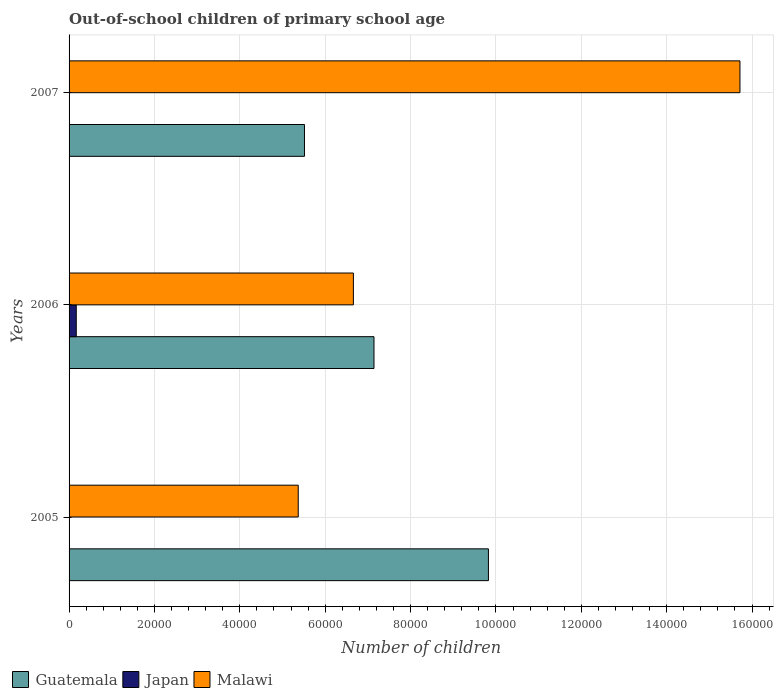How many different coloured bars are there?
Ensure brevity in your answer.  3. Are the number of bars on each tick of the Y-axis equal?
Your response must be concise. Yes. How many bars are there on the 2nd tick from the bottom?
Make the answer very short. 3. What is the label of the 2nd group of bars from the top?
Provide a short and direct response. 2006. What is the number of out-of-school children in Malawi in 2007?
Ensure brevity in your answer.  1.57e+05. Across all years, what is the maximum number of out-of-school children in Malawi?
Give a very brief answer. 1.57e+05. Across all years, what is the minimum number of out-of-school children in Japan?
Your response must be concise. 58. In which year was the number of out-of-school children in Guatemala maximum?
Keep it short and to the point. 2005. In which year was the number of out-of-school children in Japan minimum?
Provide a short and direct response. 2007. What is the total number of out-of-school children in Japan in the graph?
Your answer should be compact. 1843. What is the difference between the number of out-of-school children in Malawi in 2005 and that in 2006?
Give a very brief answer. -1.29e+04. What is the difference between the number of out-of-school children in Malawi in 2006 and the number of out-of-school children in Guatemala in 2007?
Offer a very short reply. 1.15e+04. What is the average number of out-of-school children in Malawi per year?
Make the answer very short. 9.25e+04. In the year 2007, what is the difference between the number of out-of-school children in Guatemala and number of out-of-school children in Malawi?
Give a very brief answer. -1.02e+05. In how many years, is the number of out-of-school children in Malawi greater than 144000 ?
Give a very brief answer. 1. What is the ratio of the number of out-of-school children in Malawi in 2006 to that in 2007?
Keep it short and to the point. 0.42. What is the difference between the highest and the second highest number of out-of-school children in Guatemala?
Keep it short and to the point. 2.68e+04. What is the difference between the highest and the lowest number of out-of-school children in Guatemala?
Ensure brevity in your answer.  4.31e+04. In how many years, is the number of out-of-school children in Guatemala greater than the average number of out-of-school children in Guatemala taken over all years?
Make the answer very short. 1. Is the sum of the number of out-of-school children in Japan in 2005 and 2007 greater than the maximum number of out-of-school children in Malawi across all years?
Provide a succinct answer. No. What does the 1st bar from the top in 2005 represents?
Keep it short and to the point. Malawi. What does the 2nd bar from the bottom in 2005 represents?
Offer a terse response. Japan. How many bars are there?
Provide a succinct answer. 9. Are all the bars in the graph horizontal?
Your response must be concise. Yes. How many years are there in the graph?
Give a very brief answer. 3. What is the difference between two consecutive major ticks on the X-axis?
Offer a terse response. 2.00e+04. Does the graph contain any zero values?
Your response must be concise. No. Does the graph contain grids?
Ensure brevity in your answer.  Yes. How are the legend labels stacked?
Provide a succinct answer. Horizontal. What is the title of the graph?
Your answer should be very brief. Out-of-school children of primary school age. What is the label or title of the X-axis?
Keep it short and to the point. Number of children. What is the label or title of the Y-axis?
Offer a terse response. Years. What is the Number of children in Guatemala in 2005?
Provide a succinct answer. 9.82e+04. What is the Number of children in Malawi in 2005?
Make the answer very short. 5.37e+04. What is the Number of children in Guatemala in 2006?
Offer a terse response. 7.14e+04. What is the Number of children of Japan in 2006?
Your response must be concise. 1685. What is the Number of children in Malawi in 2006?
Your response must be concise. 6.66e+04. What is the Number of children in Guatemala in 2007?
Provide a succinct answer. 5.51e+04. What is the Number of children in Malawi in 2007?
Your answer should be very brief. 1.57e+05. Across all years, what is the maximum Number of children in Guatemala?
Make the answer very short. 9.82e+04. Across all years, what is the maximum Number of children in Japan?
Provide a short and direct response. 1685. Across all years, what is the maximum Number of children in Malawi?
Offer a terse response. 1.57e+05. Across all years, what is the minimum Number of children in Guatemala?
Provide a short and direct response. 5.51e+04. Across all years, what is the minimum Number of children of Malawi?
Offer a terse response. 5.37e+04. What is the total Number of children in Guatemala in the graph?
Offer a very short reply. 2.25e+05. What is the total Number of children in Japan in the graph?
Provide a succinct answer. 1843. What is the total Number of children of Malawi in the graph?
Provide a succinct answer. 2.77e+05. What is the difference between the Number of children of Guatemala in 2005 and that in 2006?
Your answer should be very brief. 2.68e+04. What is the difference between the Number of children of Japan in 2005 and that in 2006?
Your answer should be very brief. -1585. What is the difference between the Number of children in Malawi in 2005 and that in 2006?
Keep it short and to the point. -1.29e+04. What is the difference between the Number of children in Guatemala in 2005 and that in 2007?
Offer a very short reply. 4.31e+04. What is the difference between the Number of children in Japan in 2005 and that in 2007?
Keep it short and to the point. 42. What is the difference between the Number of children of Malawi in 2005 and that in 2007?
Give a very brief answer. -1.03e+05. What is the difference between the Number of children in Guatemala in 2006 and that in 2007?
Give a very brief answer. 1.63e+04. What is the difference between the Number of children of Japan in 2006 and that in 2007?
Your response must be concise. 1627. What is the difference between the Number of children in Malawi in 2006 and that in 2007?
Make the answer very short. -9.06e+04. What is the difference between the Number of children in Guatemala in 2005 and the Number of children in Japan in 2006?
Ensure brevity in your answer.  9.66e+04. What is the difference between the Number of children in Guatemala in 2005 and the Number of children in Malawi in 2006?
Provide a succinct answer. 3.16e+04. What is the difference between the Number of children in Japan in 2005 and the Number of children in Malawi in 2006?
Give a very brief answer. -6.65e+04. What is the difference between the Number of children in Guatemala in 2005 and the Number of children in Japan in 2007?
Offer a very short reply. 9.82e+04. What is the difference between the Number of children in Guatemala in 2005 and the Number of children in Malawi in 2007?
Provide a succinct answer. -5.89e+04. What is the difference between the Number of children of Japan in 2005 and the Number of children of Malawi in 2007?
Ensure brevity in your answer.  -1.57e+05. What is the difference between the Number of children in Guatemala in 2006 and the Number of children in Japan in 2007?
Keep it short and to the point. 7.14e+04. What is the difference between the Number of children of Guatemala in 2006 and the Number of children of Malawi in 2007?
Make the answer very short. -8.57e+04. What is the difference between the Number of children of Japan in 2006 and the Number of children of Malawi in 2007?
Provide a succinct answer. -1.55e+05. What is the average Number of children in Guatemala per year?
Provide a succinct answer. 7.49e+04. What is the average Number of children of Japan per year?
Give a very brief answer. 614.33. What is the average Number of children in Malawi per year?
Offer a very short reply. 9.25e+04. In the year 2005, what is the difference between the Number of children of Guatemala and Number of children of Japan?
Keep it short and to the point. 9.81e+04. In the year 2005, what is the difference between the Number of children of Guatemala and Number of children of Malawi?
Your response must be concise. 4.46e+04. In the year 2005, what is the difference between the Number of children in Japan and Number of children in Malawi?
Your answer should be compact. -5.36e+04. In the year 2006, what is the difference between the Number of children in Guatemala and Number of children in Japan?
Offer a terse response. 6.97e+04. In the year 2006, what is the difference between the Number of children in Guatemala and Number of children in Malawi?
Ensure brevity in your answer.  4827. In the year 2006, what is the difference between the Number of children in Japan and Number of children in Malawi?
Provide a succinct answer. -6.49e+04. In the year 2007, what is the difference between the Number of children of Guatemala and Number of children of Japan?
Offer a terse response. 5.51e+04. In the year 2007, what is the difference between the Number of children in Guatemala and Number of children in Malawi?
Your answer should be compact. -1.02e+05. In the year 2007, what is the difference between the Number of children of Japan and Number of children of Malawi?
Your answer should be very brief. -1.57e+05. What is the ratio of the Number of children of Guatemala in 2005 to that in 2006?
Your answer should be very brief. 1.38. What is the ratio of the Number of children in Japan in 2005 to that in 2006?
Your answer should be compact. 0.06. What is the ratio of the Number of children in Malawi in 2005 to that in 2006?
Ensure brevity in your answer.  0.81. What is the ratio of the Number of children of Guatemala in 2005 to that in 2007?
Give a very brief answer. 1.78. What is the ratio of the Number of children of Japan in 2005 to that in 2007?
Your answer should be compact. 1.72. What is the ratio of the Number of children in Malawi in 2005 to that in 2007?
Give a very brief answer. 0.34. What is the ratio of the Number of children of Guatemala in 2006 to that in 2007?
Ensure brevity in your answer.  1.3. What is the ratio of the Number of children of Japan in 2006 to that in 2007?
Your answer should be very brief. 29.05. What is the ratio of the Number of children of Malawi in 2006 to that in 2007?
Provide a short and direct response. 0.42. What is the difference between the highest and the second highest Number of children of Guatemala?
Ensure brevity in your answer.  2.68e+04. What is the difference between the highest and the second highest Number of children in Japan?
Ensure brevity in your answer.  1585. What is the difference between the highest and the second highest Number of children in Malawi?
Keep it short and to the point. 9.06e+04. What is the difference between the highest and the lowest Number of children in Guatemala?
Offer a terse response. 4.31e+04. What is the difference between the highest and the lowest Number of children in Japan?
Provide a succinct answer. 1627. What is the difference between the highest and the lowest Number of children of Malawi?
Provide a succinct answer. 1.03e+05. 